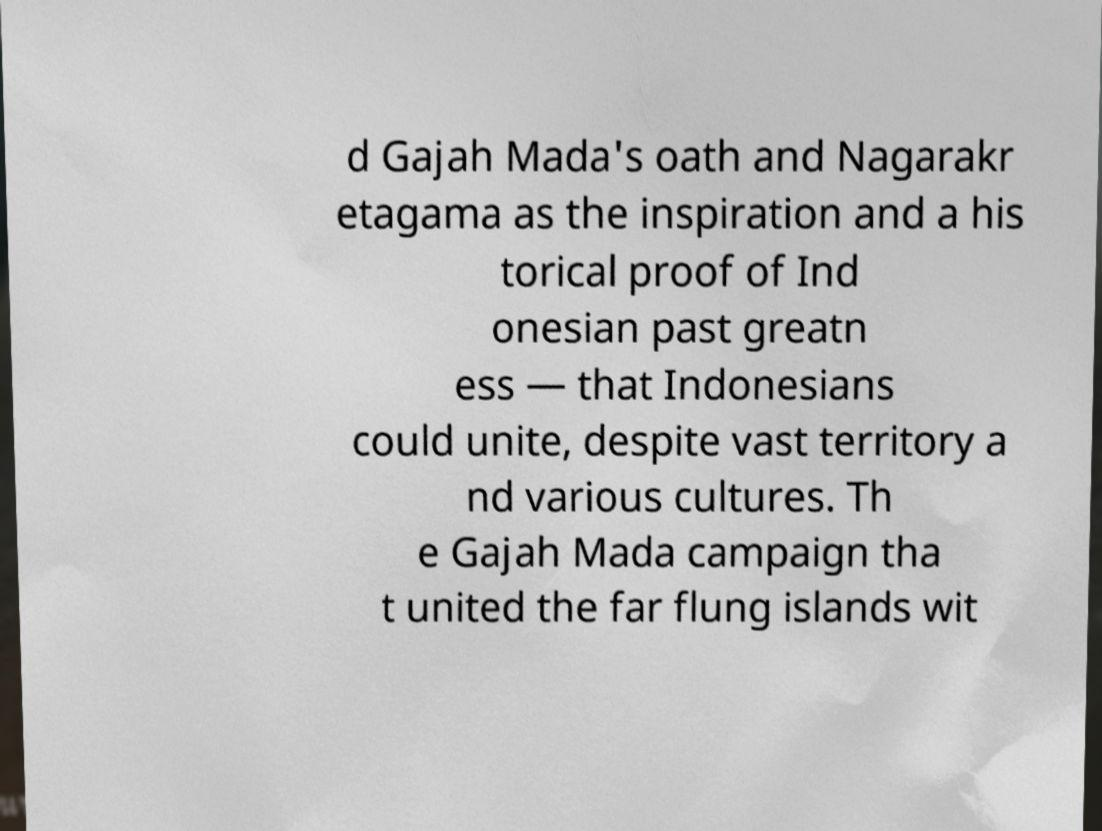Can you accurately transcribe the text from the provided image for me? d Gajah Mada's oath and Nagarakr etagama as the inspiration and a his torical proof of Ind onesian past greatn ess — that Indonesians could unite, despite vast territory a nd various cultures. Th e Gajah Mada campaign tha t united the far flung islands wit 